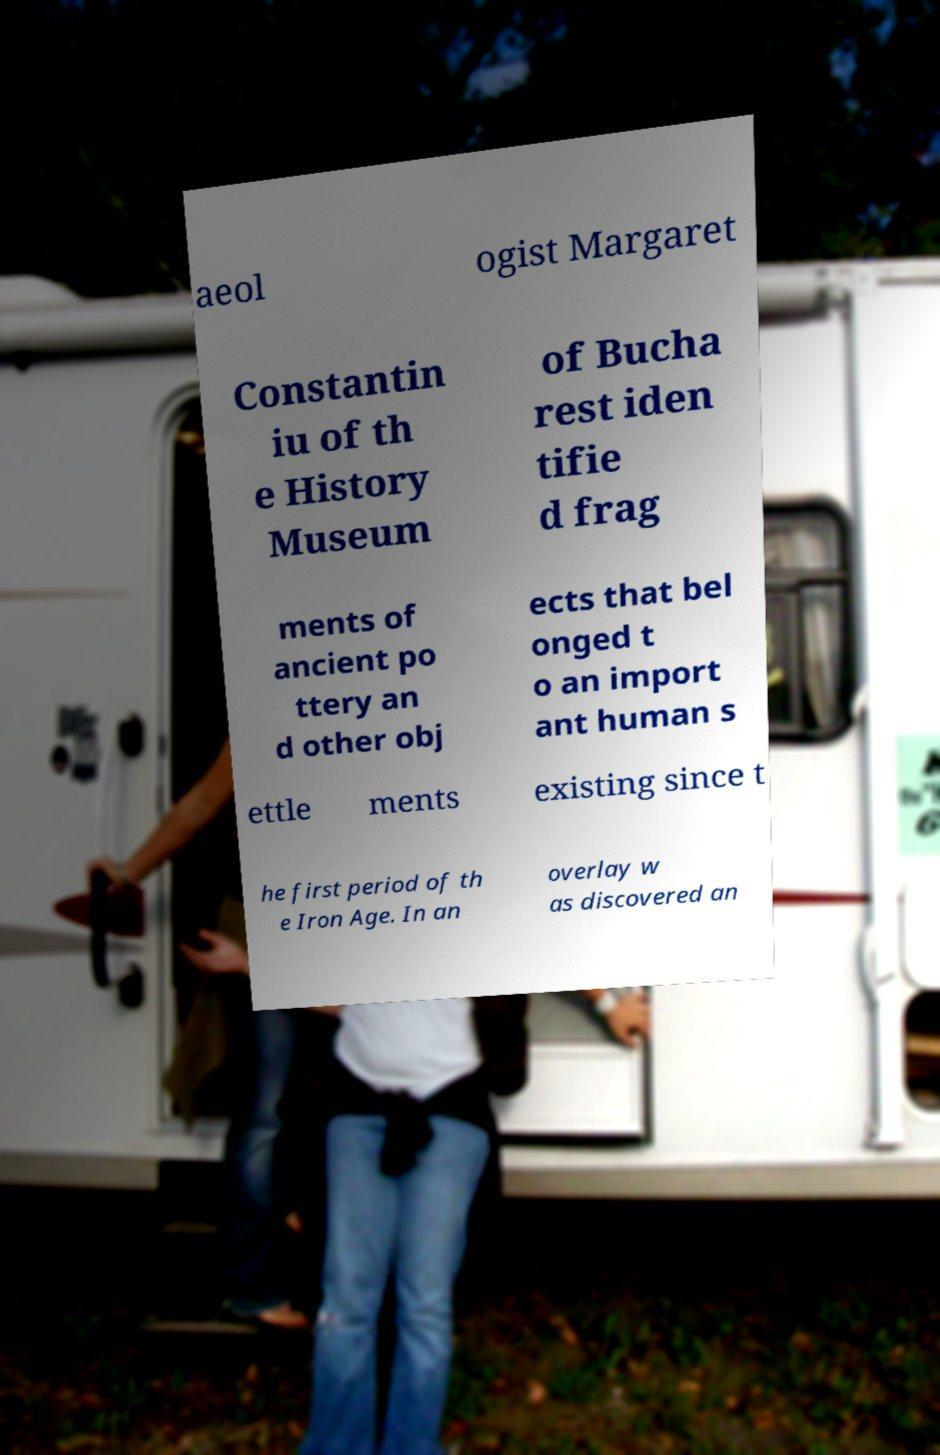Please read and relay the text visible in this image. What does it say? aeol ogist Margaret Constantin iu of th e History Museum of Bucha rest iden tifie d frag ments of ancient po ttery an d other obj ects that bel onged t o an import ant human s ettle ments existing since t he first period of th e Iron Age. In an overlay w as discovered an 